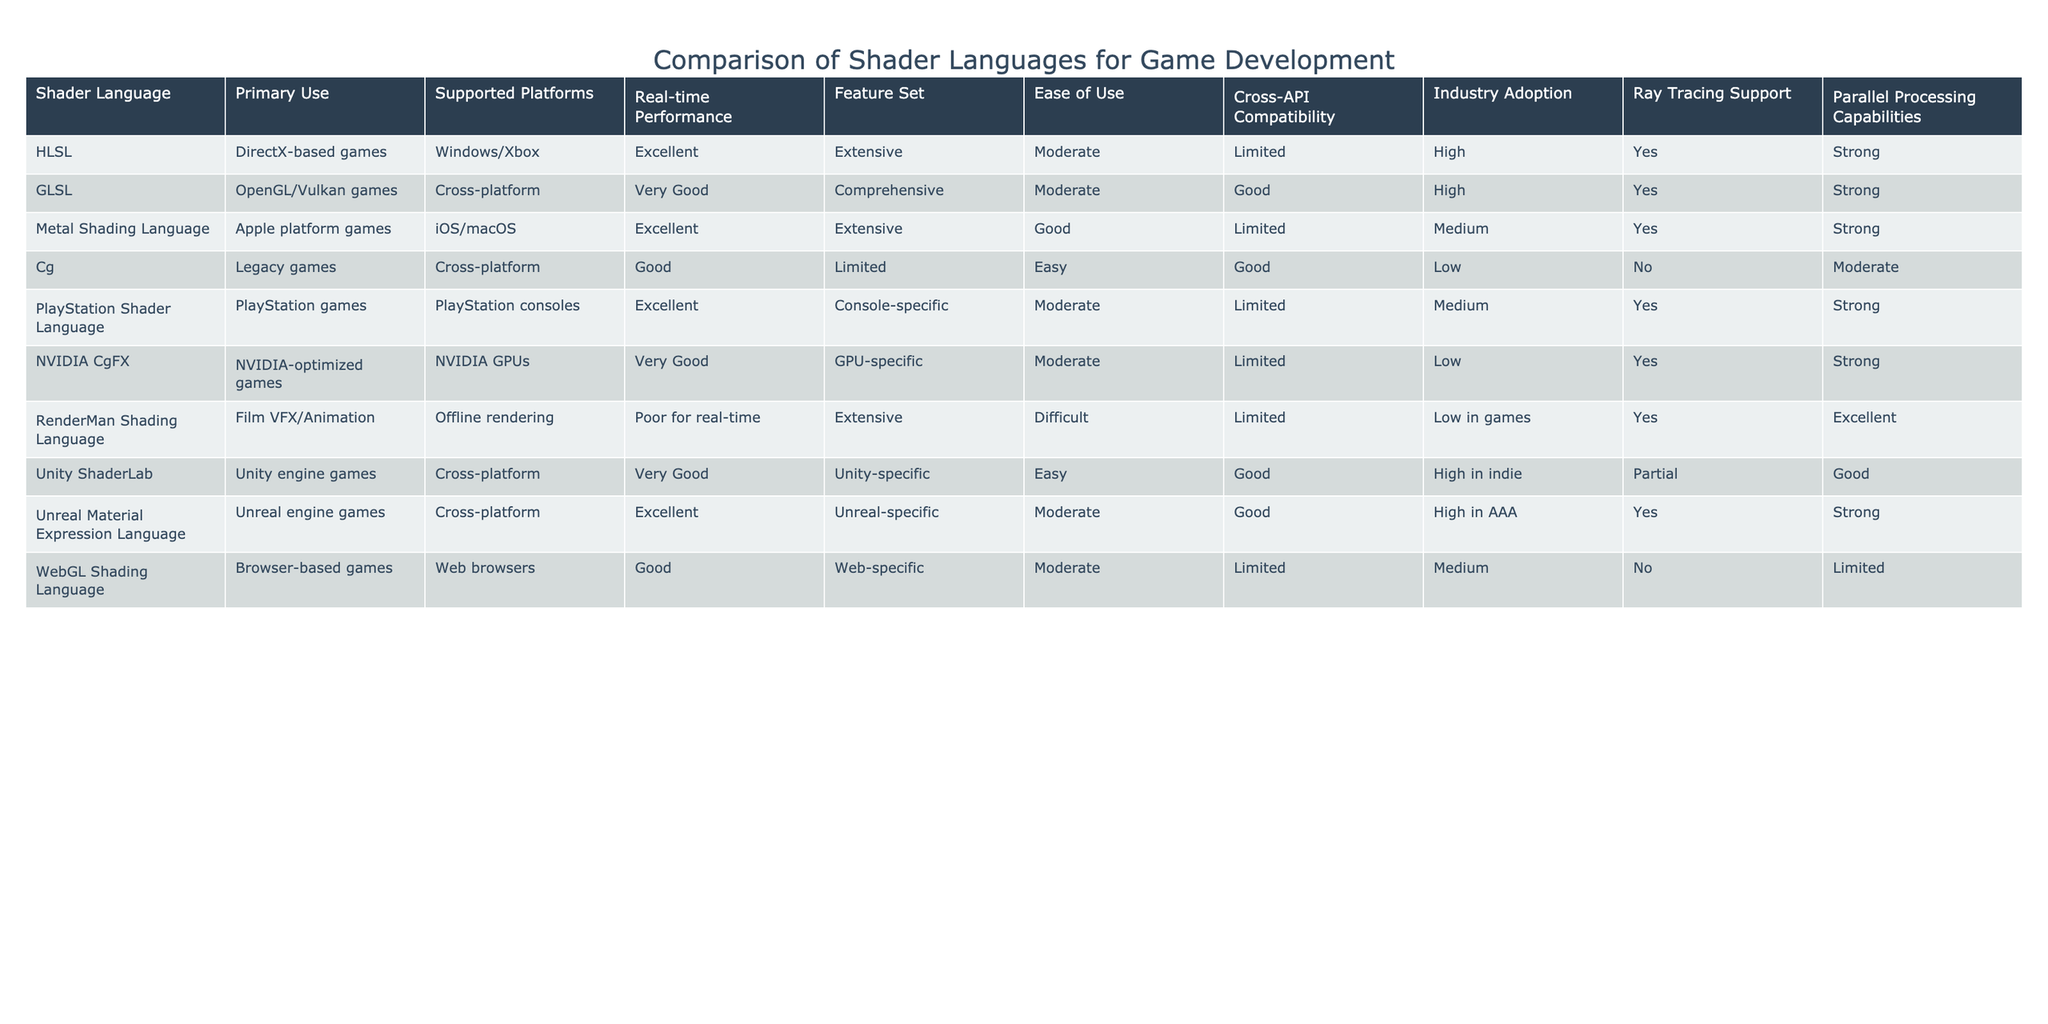What is the primary use of HLSL? The table shows that HLSL is used for DirectX-based games.
Answer: DirectX-based games Which shader language supports parallel processing capabilities? The table indicates that HLSL, GLSL, Metal Shading Language, PlayStation Shader Language, and Unreal Material Expression Language all support strong parallel processing capabilities.
Answer: HLSL, GLSL, Metal Shading Language, PlayStation Shader Language, Unreal Material Expression Language Is Cg widely adopted in the industry? The table specifies that Cg has low industry adoption according to its Industry Adoption column.
Answer: No What is the real-time performance for Unity ShaderLab? The real-time performance rating for Unity ShaderLab is Very Good according to the table.
Answer: Very Good Which shader languages have ray tracing support? Referring to the table, HLSL, GLSL, Metal Shading Language, PlayStation Shader Language, NVIDIA CgFX, Unreal Material Expression Language have ray tracing support.
Answer: HLSL, GLSL, Metal Shading Language, PlayStation Shader Language, NVIDIA CgFX, Unreal Material Expression Language How does the ease of use of GLSL compare to Cg? The table indicates that both GLSL and Cg have a Moderate and Easy ease of use rating, respectively, showing that GLSL is somewhat more difficult to use than Cg.
Answer: GLSL is more difficult What shader languages are primarily used for offline rendering? Based on the table, RenderMan Shading Language is specified for offline rendering use cases.
Answer: RenderMan Shading Language Which shader language has excellent real-time performance but limited cross-API compatibility? According to the table, Metal Shading Language fits those criteria as it has excellent real-time performance and limited cross-API compatibility.
Answer: Metal Shading Language What is the average industry adoption rating for shader languages that support ray tracing? From the table, the languages that support ray tracing are HLSL, GLSL, Metal Shading Language, PlayStation Shader Language, NVIDIA CgFX, and Unreal Material Expression Language. The industry adoption ratings are High, High, Medium, Medium, Low, and High respectively. Thus, the average is calculated as (High + High + Medium + Medium + Low + High) or approximated to be above average, which can be interpreted as above average adoption in general.
Answer: Above Average Which shader language has the best real-time performance for web-based applications? The table state that the WebGL Shading Language has Good real-time performance specifically for web-based applications.
Answer: Good 